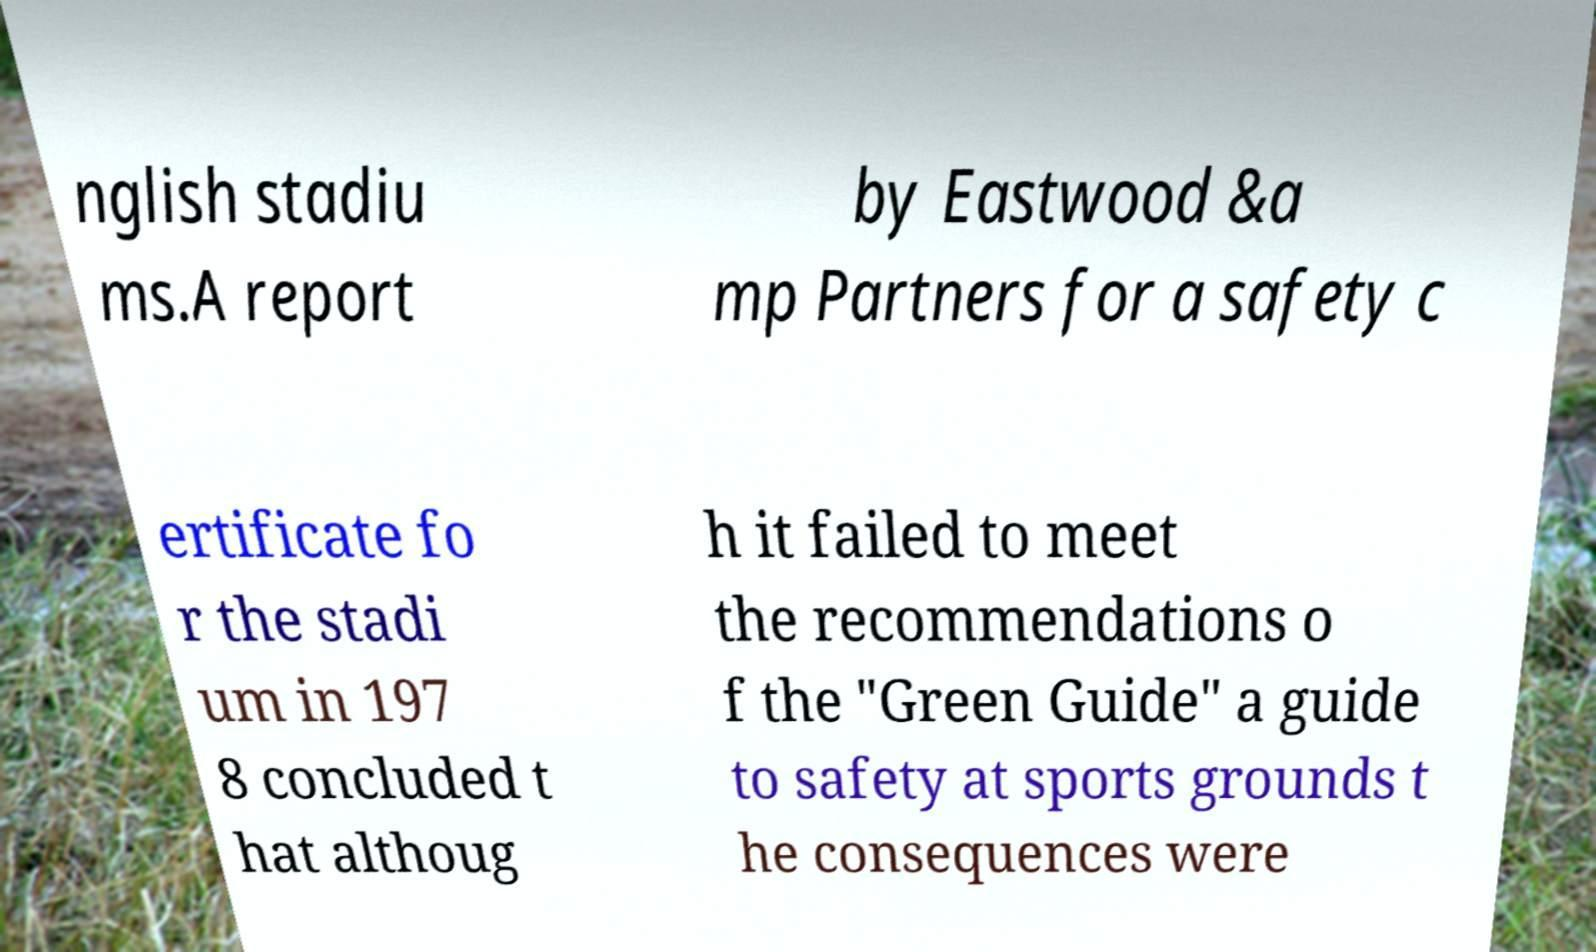Can you accurately transcribe the text from the provided image for me? nglish stadiu ms.A report by Eastwood &a mp Partners for a safety c ertificate fo r the stadi um in 197 8 concluded t hat althoug h it failed to meet the recommendations o f the "Green Guide" a guide to safety at sports grounds t he consequences were 